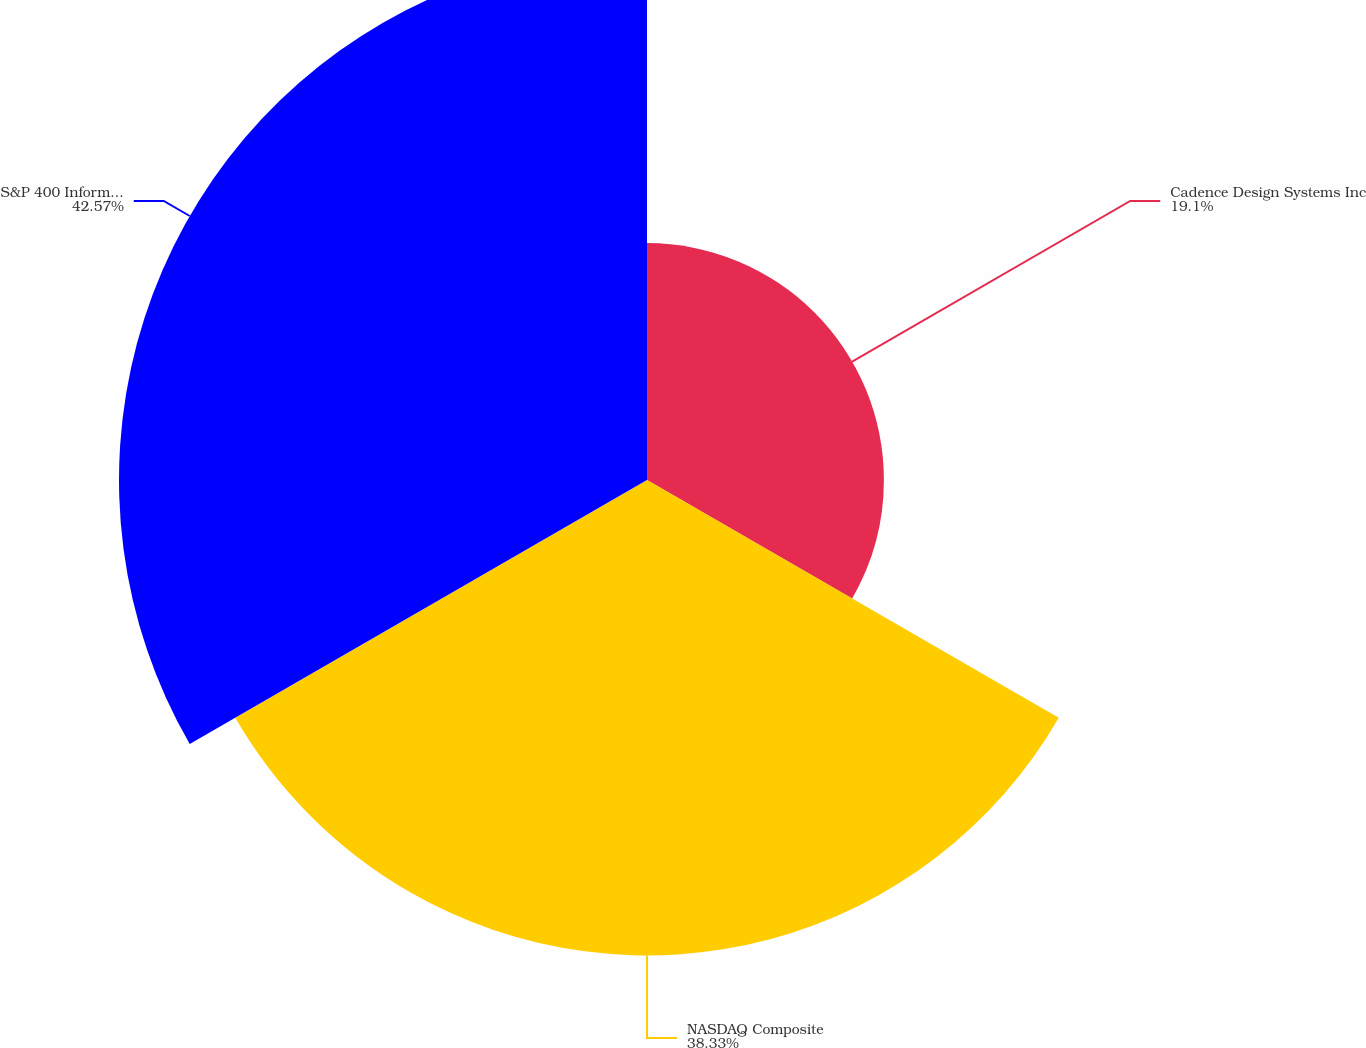Convert chart to OTSL. <chart><loc_0><loc_0><loc_500><loc_500><pie_chart><fcel>Cadence Design Systems Inc<fcel>NASDAQ Composite<fcel>S&P 400 Information Technology<nl><fcel>19.1%<fcel>38.33%<fcel>42.57%<nl></chart> 